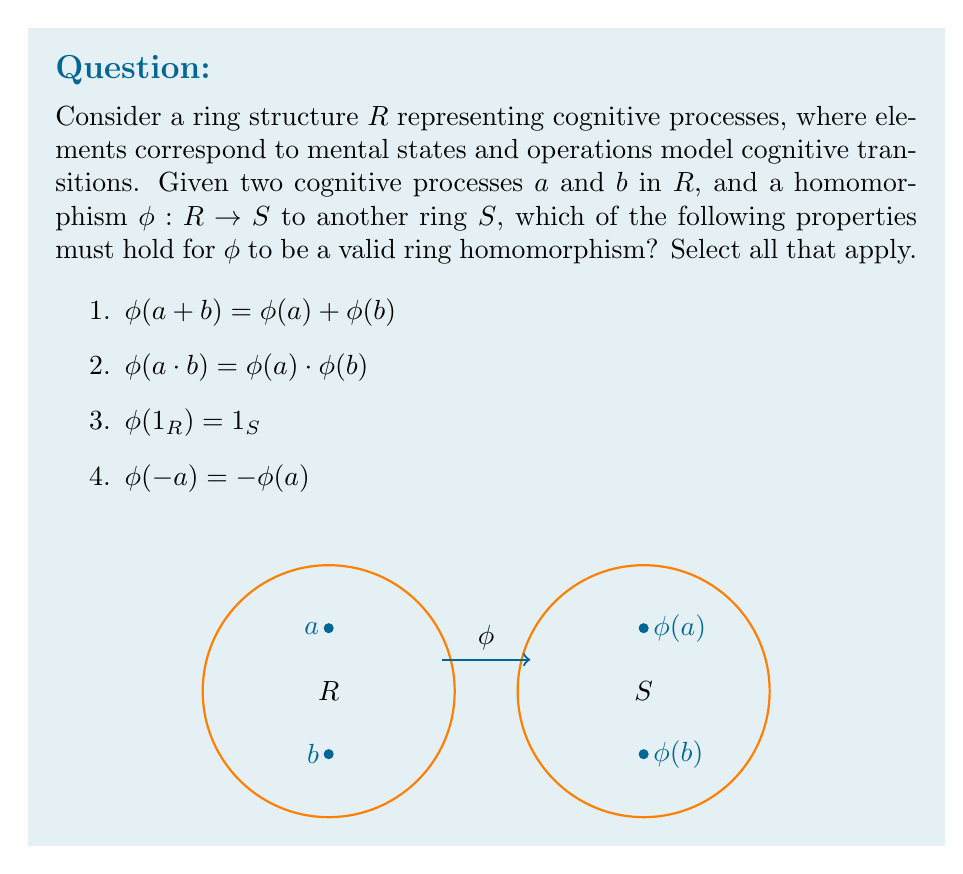Show me your answer to this math problem. To determine which properties must hold for $\phi$ to be a valid ring homomorphism, let's examine each option:

1. $\phi(a + b) = \phi(a) + \phi(b)$
This property is essential for a ring homomorphism. It preserves the additive structure of the ring, ensuring that the mapping of the sum of two cognitive processes is equal to the sum of their individual mappings.

2. $\phi(a \cdot b) = \phi(a) \cdot \phi(b)$
This property is also crucial for a ring homomorphism. It preserves the multiplicative structure of the ring, ensuring that the mapping of the product (or composition) of two cognitive processes is equal to the product of their individual mappings.

3. $\phi(1_R) = 1_S$
This property is not necessary for a general ring homomorphism. It is only required for a unital ring homomorphism. Since the question doesn't specify whether R and S are unital rings, we cannot assume this property must hold.

4. $\phi(-a) = -\phi(a)$
This property is not explicitly required for a ring homomorphism. However, it can be derived from property 1:

$\phi(a + (-a)) = \phi(0) = 0_S$
$\phi(a) + \phi(-a) = 0_S$
$\phi(-a) = -\phi(a)$

Therefore, while this property holds for ring homomorphisms, it's not a defining property but rather a consequence of property 1.

In the context of cognitive processes, these properties ensure that the structural relationships between mental states are preserved when mapped to another system. This is crucial for studying how digital simulations might accurately represent or transform cognitive processes.
Answer: 1 and 2 